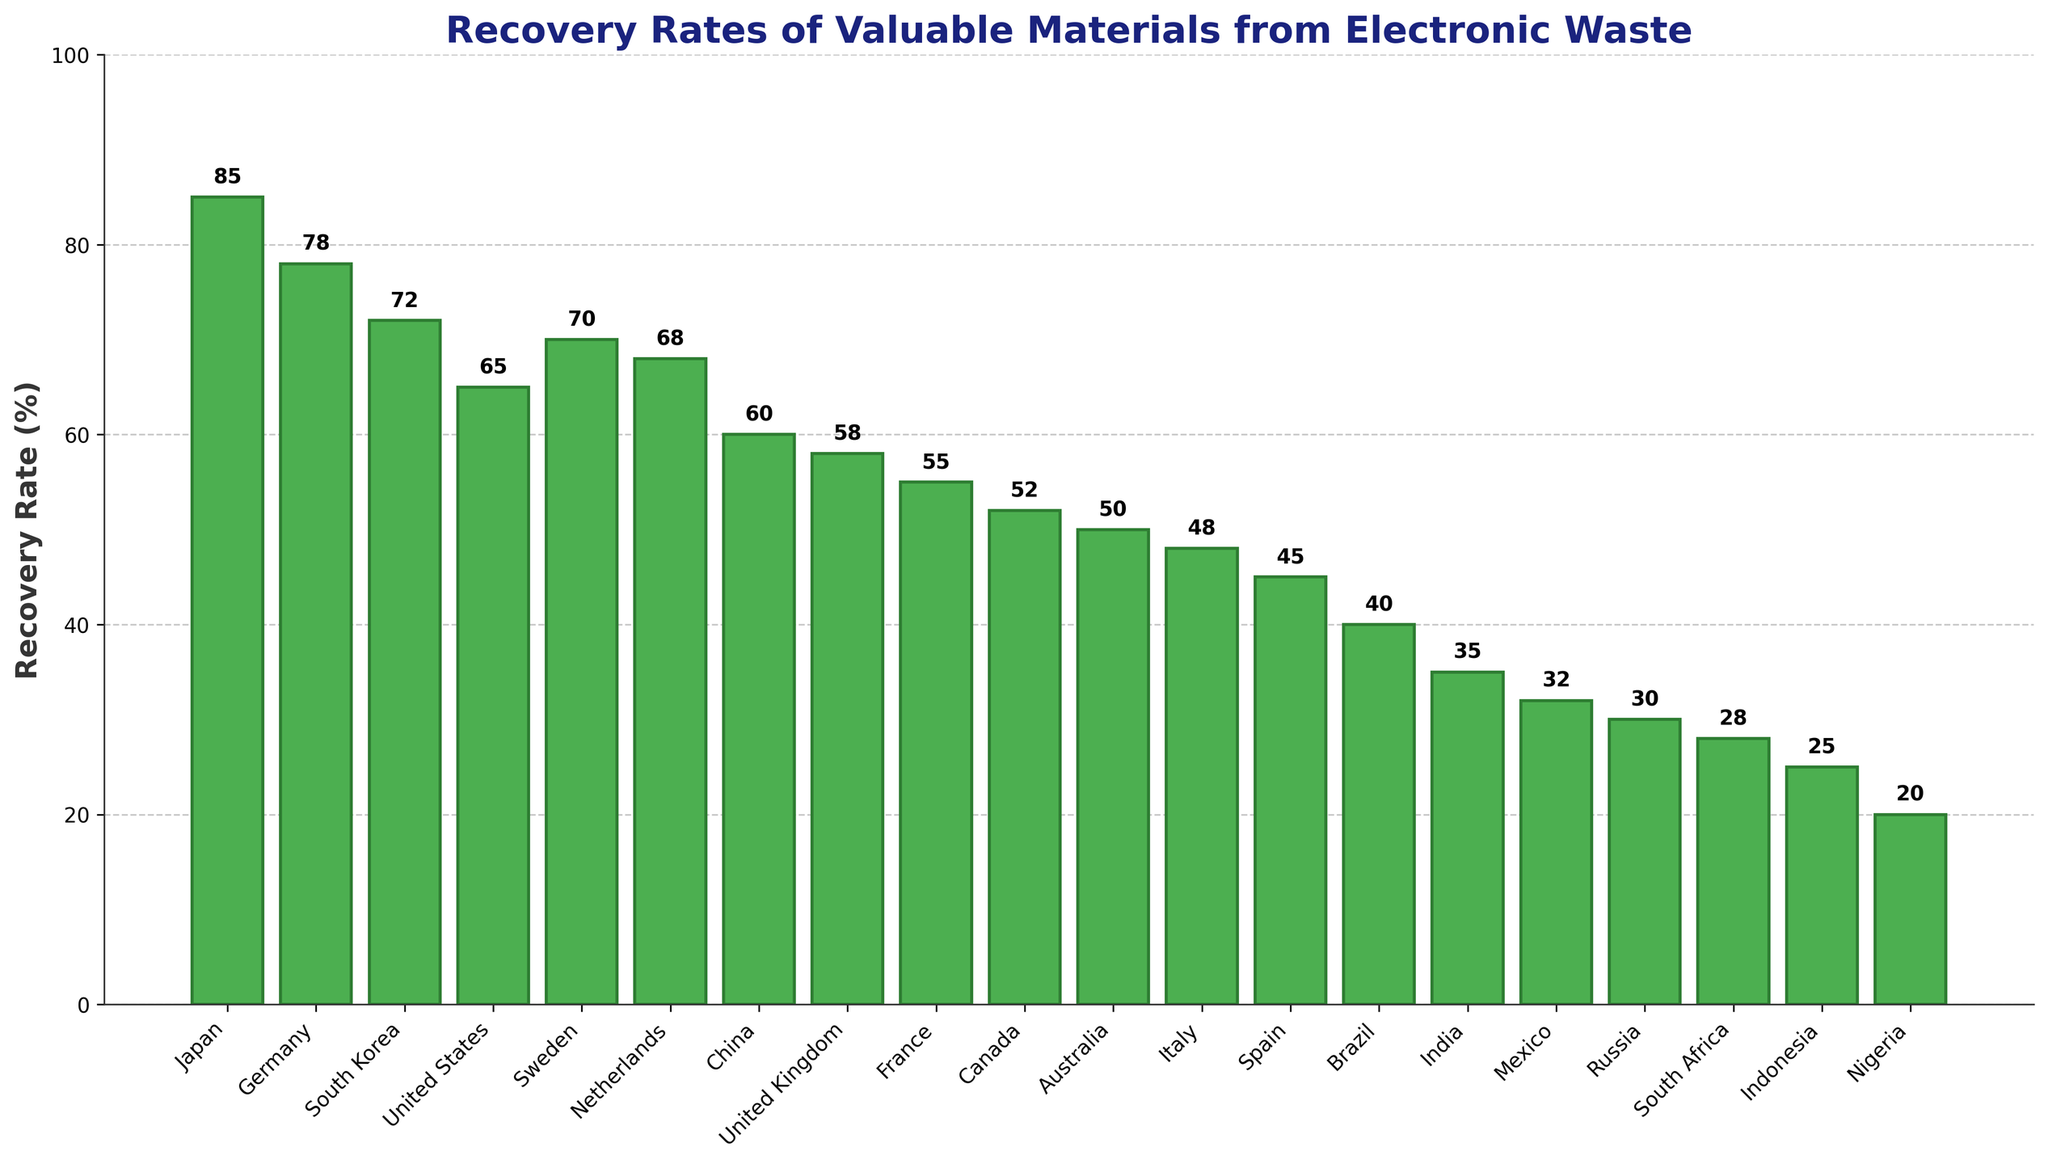What's the recovery rate of valuable materials from electronic waste in Japan? The bar representing Japan shows a recovery rate of 85%.
Answer: 85% Which country has the lowest recovery rate? The bar for Nigeria is the shortest, indicating the lowest recovery rate of 20%.
Answer: Nigeria What is the difference in recovery rates between Japan and Nigeria? The recovery rate for Japan is 85% and for Nigeria is 20%. The difference is 85% - 20% = 65%.
Answer: 65% Arrange Germany, South Korea, and the United States by their recovery rates in ascending order. The recovery rates are: Germany - 78%, South Korea - 72%, United States - 65%. Arranged in ascending order: United States (65%), South Korea (72%), Germany (78%).
Answer: United States, South Korea, Germany What is the average recovery rate of the top 5 countries? The top 5 countries by recovery rate are Japan (85%), Germany (78%), South Korea (72%), Sweden (70%), and Netherlands (68%). The average is (85 + 78 + 72 + 70 + 68) / 5 = 373 / 5 = 74.6%.
Answer: 74.6% Which countries have a recovery rate greater than 60% but less than 70%? Looking at the bars, the countries within this range are South Korea (72%), Sweden (70%), Netherlands (68%), China (60%). However, 60% is included, so the valid countries are Sweden (70%) and Netherlands (68%).
Answer: Sweden, Netherlands What is the median recovery rate of all the countries? Ordering the recovery rates from highest to lowest: 85, 78, 72, 70, 68, 65, 60, 58, 55, 52, 50, 48, 45, 40, 35, 32, 30, 28, 25, 20. The median is the middle value, which is the average of the 10th and 11th values: (52 + 50) / 2 = 51%.
Answer: 51% Which country shows approximately half the recovery rate of Japan? Japan's recovery rate is 85%. The country closest to having half of that is South Africa with a recovery rate of 28%, which is roughly half of 85%.
Answer: South Africa How many countries have a recovery rate less than the United States? The United States has a recovery rate of 65%. Counting the bars below this level, we get: China (60%), United Kingdom (58%), France (55%), Canada (52%), Australia (50%), Italy (48%), Spain (45%), Brazil (40%), India (35%), Mexico (32%), Russia (30%), South Africa (28%), Indonesia (25%), Nigeria (20%). So, there are 14 countries.
Answer: 14 What's the combined total recovery rate of Brazil and India? The recovery rates are: Brazil - 40%, India - 35%. The combined total is 40% + 35% = 75%.
Answer: 75% 